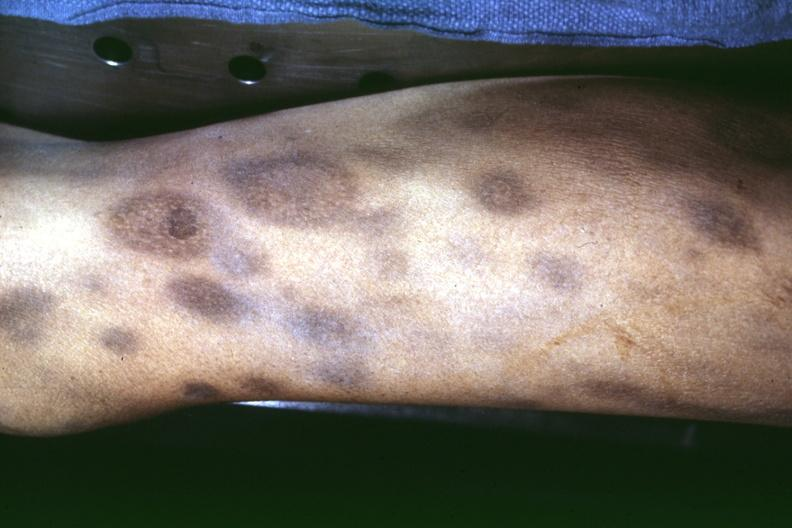where is this?
Answer the question using a single word or phrase. Skin 